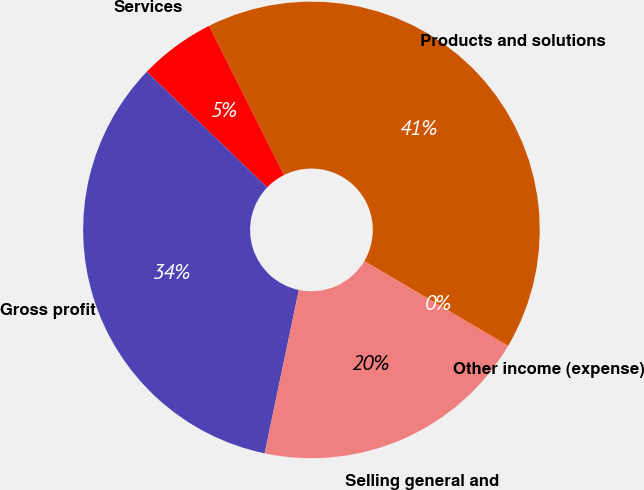Convert chart. <chart><loc_0><loc_0><loc_500><loc_500><pie_chart><fcel>Products and solutions<fcel>Services<fcel>Gross profit<fcel>Selling general and<fcel>Other income (expense)<nl><fcel>40.86%<fcel>5.43%<fcel>33.89%<fcel>19.79%<fcel>0.04%<nl></chart> 